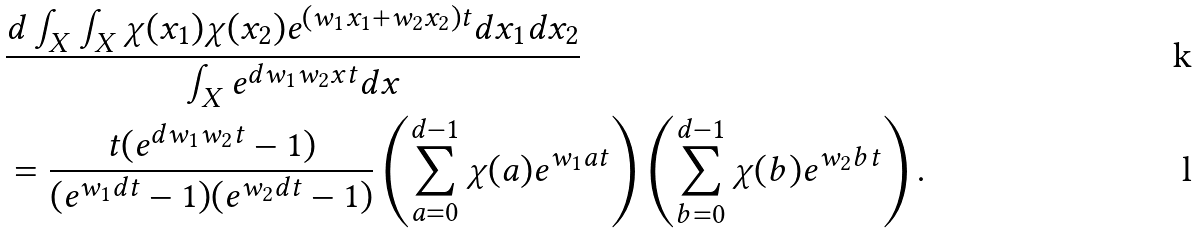Convert formula to latex. <formula><loc_0><loc_0><loc_500><loc_500>& \frac { d \int _ { X } \int _ { X } \chi ( x _ { 1 } ) \chi ( x _ { 2 } ) e ^ { ( w _ { 1 } x _ { 1 } + w _ { 2 } x _ { 2 } ) t } d x _ { 1 } d x _ { 2 } } { \int _ { X } e ^ { d w _ { 1 } w _ { 2 } x t } d x } \\ & = \frac { t ( e ^ { d w _ { 1 } w _ { 2 } t } - 1 ) } { ( e ^ { w _ { 1 } d t } - 1 ) ( e ^ { w _ { 2 } d t } - 1 ) } \left ( \sum _ { a = 0 } ^ { d - 1 } \chi ( a ) e ^ { w _ { 1 } a t } \right ) \left ( \sum _ { b = 0 } ^ { d - 1 } \chi ( b ) e ^ { w _ { 2 } b t } \right ) .</formula> 